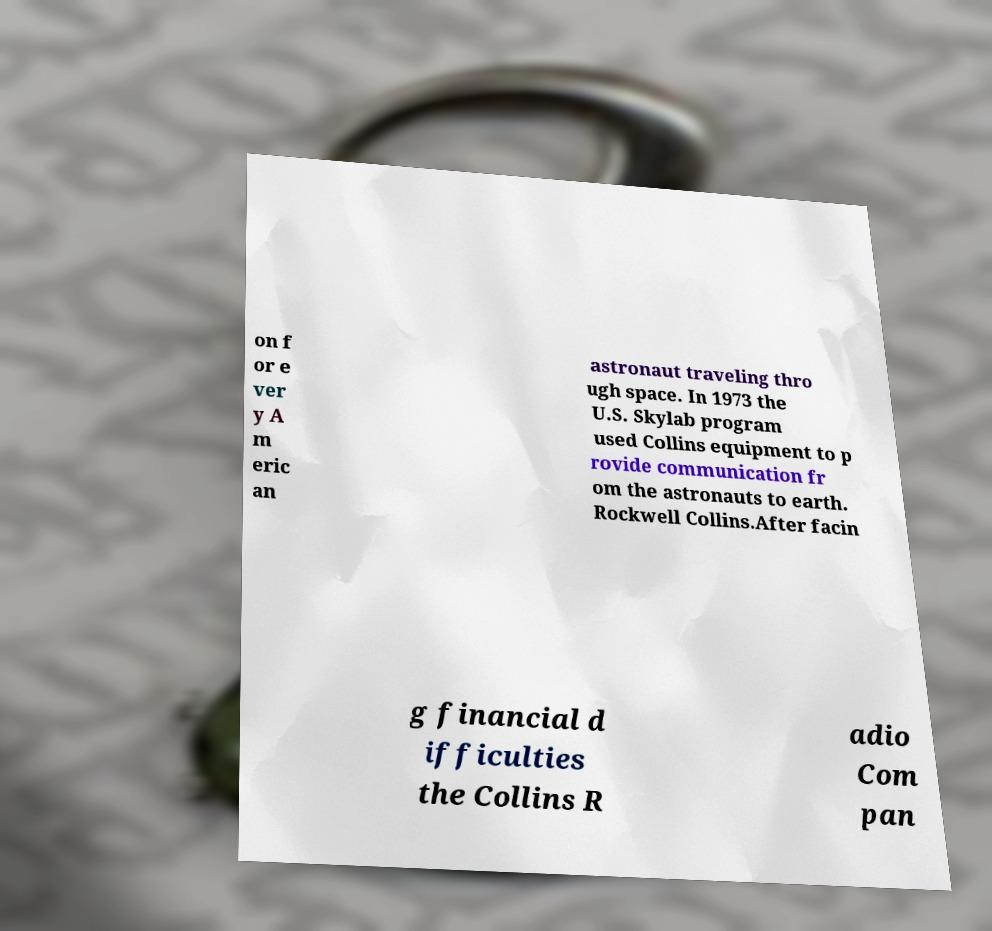What messages or text are displayed in this image? I need them in a readable, typed format. on f or e ver y A m eric an astronaut traveling thro ugh space. In 1973 the U.S. Skylab program used Collins equipment to p rovide communication fr om the astronauts to earth. Rockwell Collins.After facin g financial d ifficulties the Collins R adio Com pan 